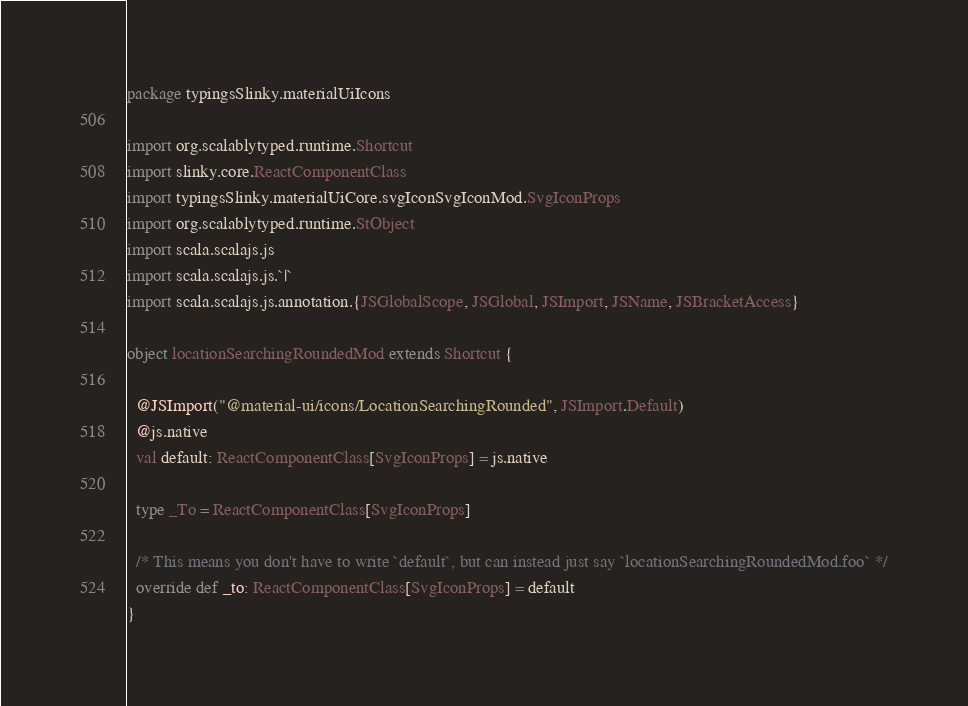Convert code to text. <code><loc_0><loc_0><loc_500><loc_500><_Scala_>package typingsSlinky.materialUiIcons

import org.scalablytyped.runtime.Shortcut
import slinky.core.ReactComponentClass
import typingsSlinky.materialUiCore.svgIconSvgIconMod.SvgIconProps
import org.scalablytyped.runtime.StObject
import scala.scalajs.js
import scala.scalajs.js.`|`
import scala.scalajs.js.annotation.{JSGlobalScope, JSGlobal, JSImport, JSName, JSBracketAccess}

object locationSearchingRoundedMod extends Shortcut {
  
  @JSImport("@material-ui/icons/LocationSearchingRounded", JSImport.Default)
  @js.native
  val default: ReactComponentClass[SvgIconProps] = js.native
  
  type _To = ReactComponentClass[SvgIconProps]
  
  /* This means you don't have to write `default`, but can instead just say `locationSearchingRoundedMod.foo` */
  override def _to: ReactComponentClass[SvgIconProps] = default
}
</code> 